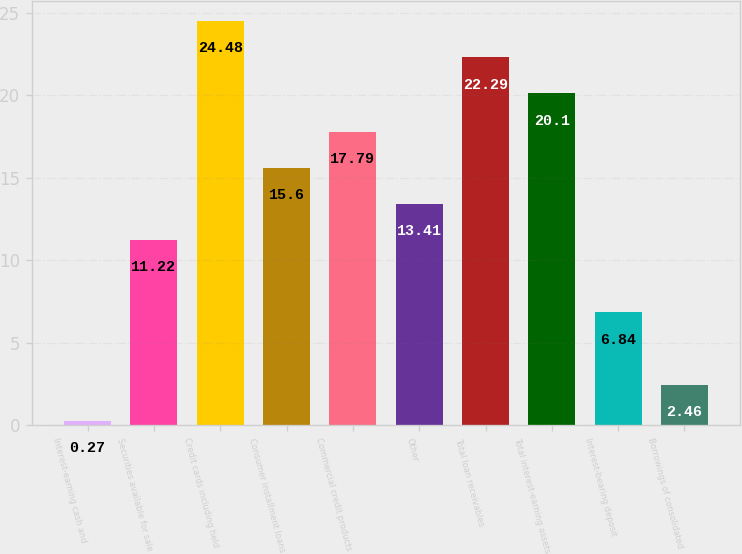Convert chart. <chart><loc_0><loc_0><loc_500><loc_500><bar_chart><fcel>Interest-earning cash and<fcel>Securities available for sale<fcel>Credit cards including held<fcel>Consumer installment loans<fcel>Commercial credit products<fcel>Other<fcel>Total loan receivables<fcel>Total interest-earning assets<fcel>Interest-bearing deposit<fcel>Borrowings of consolidated<nl><fcel>0.27<fcel>11.22<fcel>24.48<fcel>15.6<fcel>17.79<fcel>13.41<fcel>22.29<fcel>20.1<fcel>6.84<fcel>2.46<nl></chart> 